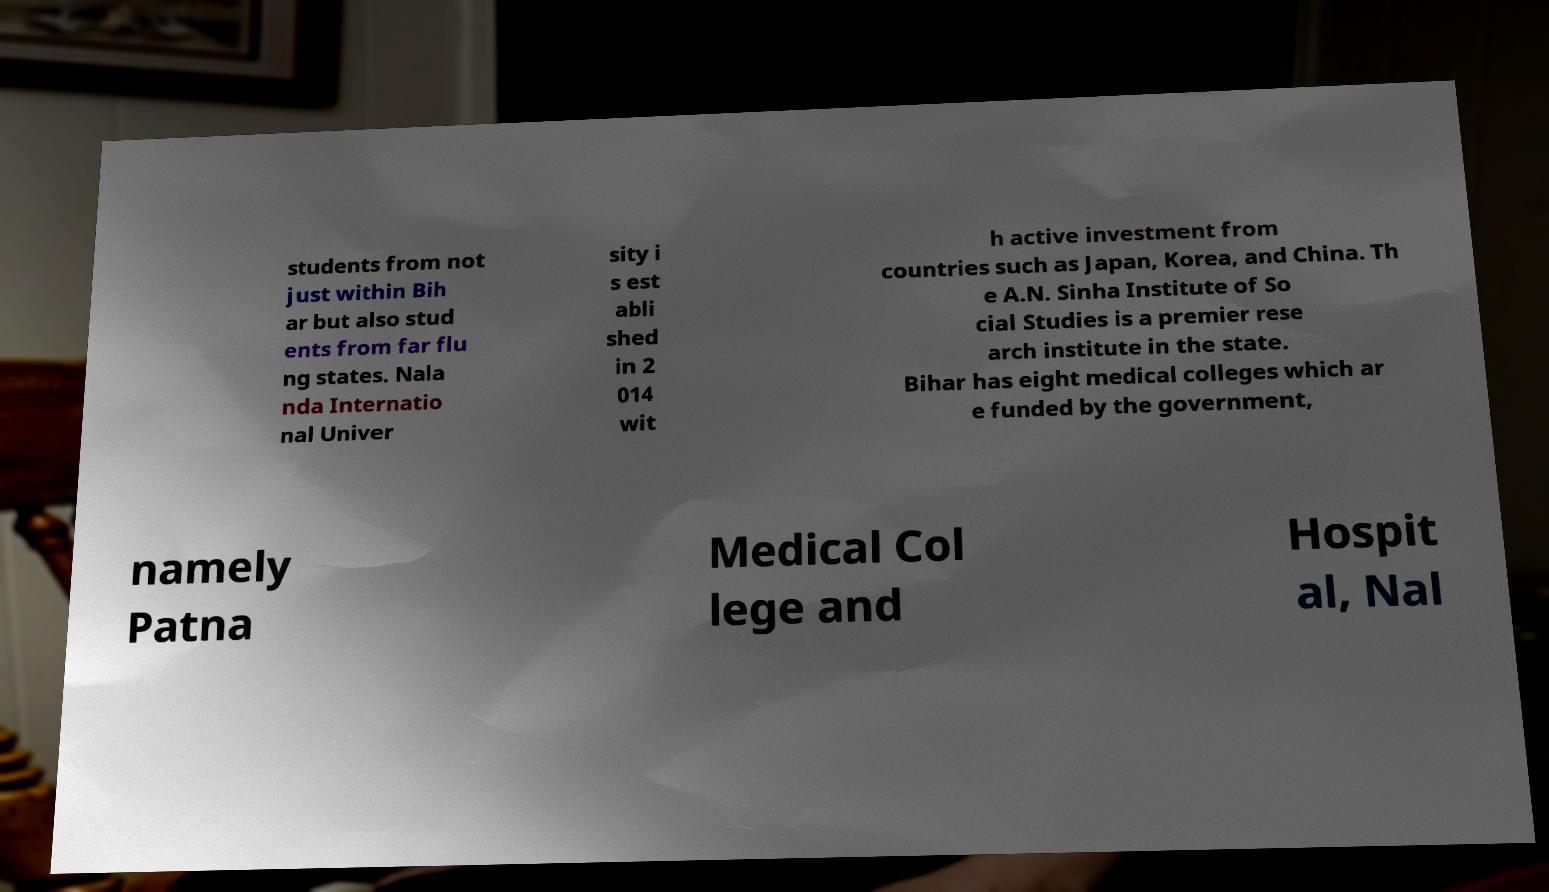Can you accurately transcribe the text from the provided image for me? students from not just within Bih ar but also stud ents from far flu ng states. Nala nda Internatio nal Univer sity i s est abli shed in 2 014 wit h active investment from countries such as Japan, Korea, and China. Th e A.N. Sinha Institute of So cial Studies is a premier rese arch institute in the state. Bihar has eight medical colleges which ar e funded by the government, namely Patna Medical Col lege and Hospit al, Nal 